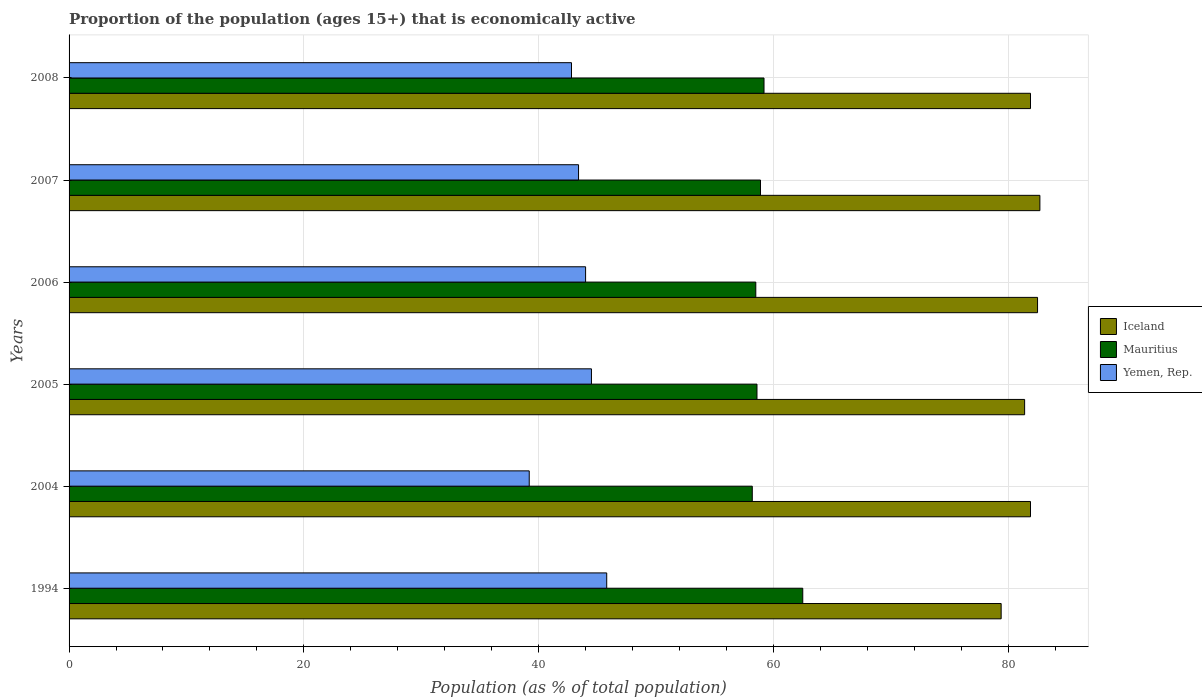How many different coloured bars are there?
Your response must be concise. 3. How many groups of bars are there?
Your answer should be very brief. 6. Are the number of bars on each tick of the Y-axis equal?
Offer a terse response. Yes. What is the label of the 2nd group of bars from the top?
Your answer should be compact. 2007. What is the proportion of the population that is economically active in Iceland in 2008?
Make the answer very short. 81.9. Across all years, what is the maximum proportion of the population that is economically active in Mauritius?
Provide a succinct answer. 62.5. Across all years, what is the minimum proportion of the population that is economically active in Iceland?
Provide a short and direct response. 79.4. In which year was the proportion of the population that is economically active in Iceland maximum?
Give a very brief answer. 2007. In which year was the proportion of the population that is economically active in Iceland minimum?
Give a very brief answer. 1994. What is the total proportion of the population that is economically active in Mauritius in the graph?
Give a very brief answer. 355.9. What is the difference between the proportion of the population that is economically active in Iceland in 2004 and that in 2007?
Give a very brief answer. -0.8. What is the average proportion of the population that is economically active in Mauritius per year?
Offer a very short reply. 59.32. In the year 2008, what is the difference between the proportion of the population that is economically active in Iceland and proportion of the population that is economically active in Yemen, Rep.?
Offer a terse response. 39.1. What is the ratio of the proportion of the population that is economically active in Mauritius in 2006 to that in 2007?
Provide a succinct answer. 0.99. What is the difference between the highest and the second highest proportion of the population that is economically active in Yemen, Rep.?
Your answer should be compact. 1.3. What is the difference between the highest and the lowest proportion of the population that is economically active in Mauritius?
Ensure brevity in your answer.  4.3. In how many years, is the proportion of the population that is economically active in Yemen, Rep. greater than the average proportion of the population that is economically active in Yemen, Rep. taken over all years?
Your response must be concise. 4. What does the 3rd bar from the top in 1994 represents?
Give a very brief answer. Iceland. What does the 3rd bar from the bottom in 1994 represents?
Your answer should be very brief. Yemen, Rep. Is it the case that in every year, the sum of the proportion of the population that is economically active in Iceland and proportion of the population that is economically active in Mauritius is greater than the proportion of the population that is economically active in Yemen, Rep.?
Keep it short and to the point. Yes. How many bars are there?
Ensure brevity in your answer.  18. How many years are there in the graph?
Your answer should be very brief. 6. What is the difference between two consecutive major ticks on the X-axis?
Make the answer very short. 20. Does the graph contain any zero values?
Provide a short and direct response. No. Does the graph contain grids?
Provide a short and direct response. Yes. What is the title of the graph?
Keep it short and to the point. Proportion of the population (ages 15+) that is economically active. What is the label or title of the X-axis?
Your response must be concise. Population (as % of total population). What is the Population (as % of total population) in Iceland in 1994?
Provide a short and direct response. 79.4. What is the Population (as % of total population) of Mauritius in 1994?
Offer a very short reply. 62.5. What is the Population (as % of total population) of Yemen, Rep. in 1994?
Your response must be concise. 45.8. What is the Population (as % of total population) of Iceland in 2004?
Your answer should be compact. 81.9. What is the Population (as % of total population) in Mauritius in 2004?
Give a very brief answer. 58.2. What is the Population (as % of total population) of Yemen, Rep. in 2004?
Give a very brief answer. 39.2. What is the Population (as % of total population) in Iceland in 2005?
Your answer should be compact. 81.4. What is the Population (as % of total population) in Mauritius in 2005?
Give a very brief answer. 58.6. What is the Population (as % of total population) in Yemen, Rep. in 2005?
Your response must be concise. 44.5. What is the Population (as % of total population) in Iceland in 2006?
Provide a short and direct response. 82.5. What is the Population (as % of total population) in Mauritius in 2006?
Your answer should be compact. 58.5. What is the Population (as % of total population) in Yemen, Rep. in 2006?
Offer a very short reply. 44. What is the Population (as % of total population) in Iceland in 2007?
Your answer should be very brief. 82.7. What is the Population (as % of total population) in Mauritius in 2007?
Keep it short and to the point. 58.9. What is the Population (as % of total population) in Yemen, Rep. in 2007?
Your answer should be compact. 43.4. What is the Population (as % of total population) in Iceland in 2008?
Offer a very short reply. 81.9. What is the Population (as % of total population) of Mauritius in 2008?
Provide a succinct answer. 59.2. What is the Population (as % of total population) in Yemen, Rep. in 2008?
Make the answer very short. 42.8. Across all years, what is the maximum Population (as % of total population) of Iceland?
Provide a short and direct response. 82.7. Across all years, what is the maximum Population (as % of total population) of Mauritius?
Ensure brevity in your answer.  62.5. Across all years, what is the maximum Population (as % of total population) in Yemen, Rep.?
Offer a very short reply. 45.8. Across all years, what is the minimum Population (as % of total population) of Iceland?
Your response must be concise. 79.4. Across all years, what is the minimum Population (as % of total population) in Mauritius?
Ensure brevity in your answer.  58.2. Across all years, what is the minimum Population (as % of total population) of Yemen, Rep.?
Your answer should be very brief. 39.2. What is the total Population (as % of total population) in Iceland in the graph?
Keep it short and to the point. 489.8. What is the total Population (as % of total population) of Mauritius in the graph?
Provide a succinct answer. 355.9. What is the total Population (as % of total population) in Yemen, Rep. in the graph?
Make the answer very short. 259.7. What is the difference between the Population (as % of total population) of Iceland in 1994 and that in 2004?
Your answer should be compact. -2.5. What is the difference between the Population (as % of total population) in Yemen, Rep. in 1994 and that in 2004?
Provide a succinct answer. 6.6. What is the difference between the Population (as % of total population) of Mauritius in 1994 and that in 2005?
Your response must be concise. 3.9. What is the difference between the Population (as % of total population) in Yemen, Rep. in 1994 and that in 2005?
Offer a very short reply. 1.3. What is the difference between the Population (as % of total population) in Iceland in 1994 and that in 2007?
Ensure brevity in your answer.  -3.3. What is the difference between the Population (as % of total population) of Mauritius in 1994 and that in 2008?
Your answer should be very brief. 3.3. What is the difference between the Population (as % of total population) of Iceland in 2004 and that in 2005?
Ensure brevity in your answer.  0.5. What is the difference between the Population (as % of total population) in Mauritius in 2004 and that in 2005?
Your response must be concise. -0.4. What is the difference between the Population (as % of total population) of Yemen, Rep. in 2004 and that in 2005?
Your answer should be very brief. -5.3. What is the difference between the Population (as % of total population) of Iceland in 2004 and that in 2006?
Your answer should be compact. -0.6. What is the difference between the Population (as % of total population) in Iceland in 2004 and that in 2007?
Offer a very short reply. -0.8. What is the difference between the Population (as % of total population) in Mauritius in 2004 and that in 2007?
Provide a short and direct response. -0.7. What is the difference between the Population (as % of total population) of Iceland in 2004 and that in 2008?
Ensure brevity in your answer.  0. What is the difference between the Population (as % of total population) in Yemen, Rep. in 2004 and that in 2008?
Your response must be concise. -3.6. What is the difference between the Population (as % of total population) of Iceland in 2005 and that in 2006?
Your answer should be compact. -1.1. What is the difference between the Population (as % of total population) in Mauritius in 2005 and that in 2006?
Offer a very short reply. 0.1. What is the difference between the Population (as % of total population) of Yemen, Rep. in 2005 and that in 2006?
Your answer should be compact. 0.5. What is the difference between the Population (as % of total population) of Iceland in 2005 and that in 2007?
Keep it short and to the point. -1.3. What is the difference between the Population (as % of total population) of Mauritius in 2005 and that in 2007?
Ensure brevity in your answer.  -0.3. What is the difference between the Population (as % of total population) of Yemen, Rep. in 2005 and that in 2007?
Provide a succinct answer. 1.1. What is the difference between the Population (as % of total population) in Iceland in 2005 and that in 2008?
Provide a succinct answer. -0.5. What is the difference between the Population (as % of total population) in Mauritius in 2005 and that in 2008?
Ensure brevity in your answer.  -0.6. What is the difference between the Population (as % of total population) of Yemen, Rep. in 2005 and that in 2008?
Offer a terse response. 1.7. What is the difference between the Population (as % of total population) of Iceland in 2006 and that in 2007?
Your response must be concise. -0.2. What is the difference between the Population (as % of total population) in Iceland in 2006 and that in 2008?
Offer a very short reply. 0.6. What is the difference between the Population (as % of total population) of Mauritius in 2006 and that in 2008?
Offer a very short reply. -0.7. What is the difference between the Population (as % of total population) in Yemen, Rep. in 2006 and that in 2008?
Your answer should be very brief. 1.2. What is the difference between the Population (as % of total population) in Iceland in 1994 and the Population (as % of total population) in Mauritius in 2004?
Your response must be concise. 21.2. What is the difference between the Population (as % of total population) of Iceland in 1994 and the Population (as % of total population) of Yemen, Rep. in 2004?
Provide a short and direct response. 40.2. What is the difference between the Population (as % of total population) in Mauritius in 1994 and the Population (as % of total population) in Yemen, Rep. in 2004?
Make the answer very short. 23.3. What is the difference between the Population (as % of total population) in Iceland in 1994 and the Population (as % of total population) in Mauritius in 2005?
Your answer should be very brief. 20.8. What is the difference between the Population (as % of total population) in Iceland in 1994 and the Population (as % of total population) in Yemen, Rep. in 2005?
Keep it short and to the point. 34.9. What is the difference between the Population (as % of total population) of Iceland in 1994 and the Population (as % of total population) of Mauritius in 2006?
Your response must be concise. 20.9. What is the difference between the Population (as % of total population) of Iceland in 1994 and the Population (as % of total population) of Yemen, Rep. in 2006?
Your response must be concise. 35.4. What is the difference between the Population (as % of total population) of Iceland in 1994 and the Population (as % of total population) of Mauritius in 2007?
Offer a terse response. 20.5. What is the difference between the Population (as % of total population) in Iceland in 1994 and the Population (as % of total population) in Yemen, Rep. in 2007?
Offer a terse response. 36. What is the difference between the Population (as % of total population) in Mauritius in 1994 and the Population (as % of total population) in Yemen, Rep. in 2007?
Offer a very short reply. 19.1. What is the difference between the Population (as % of total population) of Iceland in 1994 and the Population (as % of total population) of Mauritius in 2008?
Your response must be concise. 20.2. What is the difference between the Population (as % of total population) in Iceland in 1994 and the Population (as % of total population) in Yemen, Rep. in 2008?
Offer a terse response. 36.6. What is the difference between the Population (as % of total population) in Mauritius in 1994 and the Population (as % of total population) in Yemen, Rep. in 2008?
Ensure brevity in your answer.  19.7. What is the difference between the Population (as % of total population) in Iceland in 2004 and the Population (as % of total population) in Mauritius in 2005?
Provide a succinct answer. 23.3. What is the difference between the Population (as % of total population) of Iceland in 2004 and the Population (as % of total population) of Yemen, Rep. in 2005?
Give a very brief answer. 37.4. What is the difference between the Population (as % of total population) in Iceland in 2004 and the Population (as % of total population) in Mauritius in 2006?
Keep it short and to the point. 23.4. What is the difference between the Population (as % of total population) in Iceland in 2004 and the Population (as % of total population) in Yemen, Rep. in 2006?
Keep it short and to the point. 37.9. What is the difference between the Population (as % of total population) in Mauritius in 2004 and the Population (as % of total population) in Yemen, Rep. in 2006?
Provide a short and direct response. 14.2. What is the difference between the Population (as % of total population) of Iceland in 2004 and the Population (as % of total population) of Yemen, Rep. in 2007?
Offer a terse response. 38.5. What is the difference between the Population (as % of total population) of Iceland in 2004 and the Population (as % of total population) of Mauritius in 2008?
Ensure brevity in your answer.  22.7. What is the difference between the Population (as % of total population) of Iceland in 2004 and the Population (as % of total population) of Yemen, Rep. in 2008?
Your answer should be compact. 39.1. What is the difference between the Population (as % of total population) in Mauritius in 2004 and the Population (as % of total population) in Yemen, Rep. in 2008?
Your answer should be very brief. 15.4. What is the difference between the Population (as % of total population) of Iceland in 2005 and the Population (as % of total population) of Mauritius in 2006?
Provide a succinct answer. 22.9. What is the difference between the Population (as % of total population) of Iceland in 2005 and the Population (as % of total population) of Yemen, Rep. in 2006?
Ensure brevity in your answer.  37.4. What is the difference between the Population (as % of total population) in Mauritius in 2005 and the Population (as % of total population) in Yemen, Rep. in 2006?
Your answer should be compact. 14.6. What is the difference between the Population (as % of total population) in Iceland in 2005 and the Population (as % of total population) in Mauritius in 2007?
Offer a very short reply. 22.5. What is the difference between the Population (as % of total population) in Iceland in 2005 and the Population (as % of total population) in Yemen, Rep. in 2007?
Offer a terse response. 38. What is the difference between the Population (as % of total population) of Iceland in 2005 and the Population (as % of total population) of Mauritius in 2008?
Offer a very short reply. 22.2. What is the difference between the Population (as % of total population) in Iceland in 2005 and the Population (as % of total population) in Yemen, Rep. in 2008?
Provide a succinct answer. 38.6. What is the difference between the Population (as % of total population) of Mauritius in 2005 and the Population (as % of total population) of Yemen, Rep. in 2008?
Offer a very short reply. 15.8. What is the difference between the Population (as % of total population) in Iceland in 2006 and the Population (as % of total population) in Mauritius in 2007?
Offer a terse response. 23.6. What is the difference between the Population (as % of total population) of Iceland in 2006 and the Population (as % of total population) of Yemen, Rep. in 2007?
Offer a terse response. 39.1. What is the difference between the Population (as % of total population) of Iceland in 2006 and the Population (as % of total population) of Mauritius in 2008?
Your response must be concise. 23.3. What is the difference between the Population (as % of total population) of Iceland in 2006 and the Population (as % of total population) of Yemen, Rep. in 2008?
Offer a terse response. 39.7. What is the difference between the Population (as % of total population) of Mauritius in 2006 and the Population (as % of total population) of Yemen, Rep. in 2008?
Provide a short and direct response. 15.7. What is the difference between the Population (as % of total population) of Iceland in 2007 and the Population (as % of total population) of Mauritius in 2008?
Offer a very short reply. 23.5. What is the difference between the Population (as % of total population) of Iceland in 2007 and the Population (as % of total population) of Yemen, Rep. in 2008?
Provide a short and direct response. 39.9. What is the difference between the Population (as % of total population) of Mauritius in 2007 and the Population (as % of total population) of Yemen, Rep. in 2008?
Provide a short and direct response. 16.1. What is the average Population (as % of total population) of Iceland per year?
Offer a very short reply. 81.63. What is the average Population (as % of total population) of Mauritius per year?
Provide a succinct answer. 59.32. What is the average Population (as % of total population) of Yemen, Rep. per year?
Your answer should be compact. 43.28. In the year 1994, what is the difference between the Population (as % of total population) in Iceland and Population (as % of total population) in Yemen, Rep.?
Make the answer very short. 33.6. In the year 1994, what is the difference between the Population (as % of total population) of Mauritius and Population (as % of total population) of Yemen, Rep.?
Keep it short and to the point. 16.7. In the year 2004, what is the difference between the Population (as % of total population) in Iceland and Population (as % of total population) in Mauritius?
Your answer should be very brief. 23.7. In the year 2004, what is the difference between the Population (as % of total population) in Iceland and Population (as % of total population) in Yemen, Rep.?
Give a very brief answer. 42.7. In the year 2005, what is the difference between the Population (as % of total population) of Iceland and Population (as % of total population) of Mauritius?
Keep it short and to the point. 22.8. In the year 2005, what is the difference between the Population (as % of total population) of Iceland and Population (as % of total population) of Yemen, Rep.?
Your answer should be compact. 36.9. In the year 2005, what is the difference between the Population (as % of total population) in Mauritius and Population (as % of total population) in Yemen, Rep.?
Your answer should be compact. 14.1. In the year 2006, what is the difference between the Population (as % of total population) in Iceland and Population (as % of total population) in Yemen, Rep.?
Keep it short and to the point. 38.5. In the year 2006, what is the difference between the Population (as % of total population) of Mauritius and Population (as % of total population) of Yemen, Rep.?
Provide a short and direct response. 14.5. In the year 2007, what is the difference between the Population (as % of total population) of Iceland and Population (as % of total population) of Mauritius?
Your answer should be compact. 23.8. In the year 2007, what is the difference between the Population (as % of total population) in Iceland and Population (as % of total population) in Yemen, Rep.?
Provide a succinct answer. 39.3. In the year 2007, what is the difference between the Population (as % of total population) in Mauritius and Population (as % of total population) in Yemen, Rep.?
Provide a succinct answer. 15.5. In the year 2008, what is the difference between the Population (as % of total population) of Iceland and Population (as % of total population) of Mauritius?
Your answer should be compact. 22.7. In the year 2008, what is the difference between the Population (as % of total population) in Iceland and Population (as % of total population) in Yemen, Rep.?
Provide a short and direct response. 39.1. In the year 2008, what is the difference between the Population (as % of total population) in Mauritius and Population (as % of total population) in Yemen, Rep.?
Offer a very short reply. 16.4. What is the ratio of the Population (as % of total population) of Iceland in 1994 to that in 2004?
Your response must be concise. 0.97. What is the ratio of the Population (as % of total population) in Mauritius in 1994 to that in 2004?
Make the answer very short. 1.07. What is the ratio of the Population (as % of total population) in Yemen, Rep. in 1994 to that in 2004?
Offer a very short reply. 1.17. What is the ratio of the Population (as % of total population) of Iceland in 1994 to that in 2005?
Your answer should be very brief. 0.98. What is the ratio of the Population (as % of total population) of Mauritius in 1994 to that in 2005?
Provide a short and direct response. 1.07. What is the ratio of the Population (as % of total population) of Yemen, Rep. in 1994 to that in 2005?
Give a very brief answer. 1.03. What is the ratio of the Population (as % of total population) in Iceland in 1994 to that in 2006?
Offer a very short reply. 0.96. What is the ratio of the Population (as % of total population) in Mauritius in 1994 to that in 2006?
Provide a succinct answer. 1.07. What is the ratio of the Population (as % of total population) in Yemen, Rep. in 1994 to that in 2006?
Offer a terse response. 1.04. What is the ratio of the Population (as % of total population) of Iceland in 1994 to that in 2007?
Your answer should be very brief. 0.96. What is the ratio of the Population (as % of total population) in Mauritius in 1994 to that in 2007?
Give a very brief answer. 1.06. What is the ratio of the Population (as % of total population) of Yemen, Rep. in 1994 to that in 2007?
Make the answer very short. 1.06. What is the ratio of the Population (as % of total population) in Iceland in 1994 to that in 2008?
Give a very brief answer. 0.97. What is the ratio of the Population (as % of total population) of Mauritius in 1994 to that in 2008?
Offer a terse response. 1.06. What is the ratio of the Population (as % of total population) in Yemen, Rep. in 1994 to that in 2008?
Make the answer very short. 1.07. What is the ratio of the Population (as % of total population) in Iceland in 2004 to that in 2005?
Provide a succinct answer. 1.01. What is the ratio of the Population (as % of total population) in Mauritius in 2004 to that in 2005?
Give a very brief answer. 0.99. What is the ratio of the Population (as % of total population) of Yemen, Rep. in 2004 to that in 2005?
Give a very brief answer. 0.88. What is the ratio of the Population (as % of total population) of Mauritius in 2004 to that in 2006?
Provide a succinct answer. 0.99. What is the ratio of the Population (as % of total population) of Yemen, Rep. in 2004 to that in 2006?
Provide a succinct answer. 0.89. What is the ratio of the Population (as % of total population) of Iceland in 2004 to that in 2007?
Give a very brief answer. 0.99. What is the ratio of the Population (as % of total population) of Yemen, Rep. in 2004 to that in 2007?
Your response must be concise. 0.9. What is the ratio of the Population (as % of total population) in Iceland in 2004 to that in 2008?
Provide a short and direct response. 1. What is the ratio of the Population (as % of total population) in Mauritius in 2004 to that in 2008?
Your response must be concise. 0.98. What is the ratio of the Population (as % of total population) of Yemen, Rep. in 2004 to that in 2008?
Make the answer very short. 0.92. What is the ratio of the Population (as % of total population) of Iceland in 2005 to that in 2006?
Offer a terse response. 0.99. What is the ratio of the Population (as % of total population) in Yemen, Rep. in 2005 to that in 2006?
Give a very brief answer. 1.01. What is the ratio of the Population (as % of total population) of Iceland in 2005 to that in 2007?
Offer a terse response. 0.98. What is the ratio of the Population (as % of total population) of Yemen, Rep. in 2005 to that in 2007?
Provide a short and direct response. 1.03. What is the ratio of the Population (as % of total population) in Mauritius in 2005 to that in 2008?
Give a very brief answer. 0.99. What is the ratio of the Population (as % of total population) in Yemen, Rep. in 2005 to that in 2008?
Provide a short and direct response. 1.04. What is the ratio of the Population (as % of total population) in Iceland in 2006 to that in 2007?
Provide a short and direct response. 1. What is the ratio of the Population (as % of total population) of Yemen, Rep. in 2006 to that in 2007?
Offer a terse response. 1.01. What is the ratio of the Population (as % of total population) in Iceland in 2006 to that in 2008?
Offer a very short reply. 1.01. What is the ratio of the Population (as % of total population) of Mauritius in 2006 to that in 2008?
Make the answer very short. 0.99. What is the ratio of the Population (as % of total population) of Yemen, Rep. in 2006 to that in 2008?
Ensure brevity in your answer.  1.03. What is the ratio of the Population (as % of total population) of Iceland in 2007 to that in 2008?
Provide a succinct answer. 1.01. What is the difference between the highest and the second highest Population (as % of total population) in Iceland?
Offer a terse response. 0.2. What is the difference between the highest and the second highest Population (as % of total population) of Yemen, Rep.?
Keep it short and to the point. 1.3. What is the difference between the highest and the lowest Population (as % of total population) in Iceland?
Your response must be concise. 3.3. What is the difference between the highest and the lowest Population (as % of total population) in Mauritius?
Your response must be concise. 4.3. What is the difference between the highest and the lowest Population (as % of total population) of Yemen, Rep.?
Ensure brevity in your answer.  6.6. 